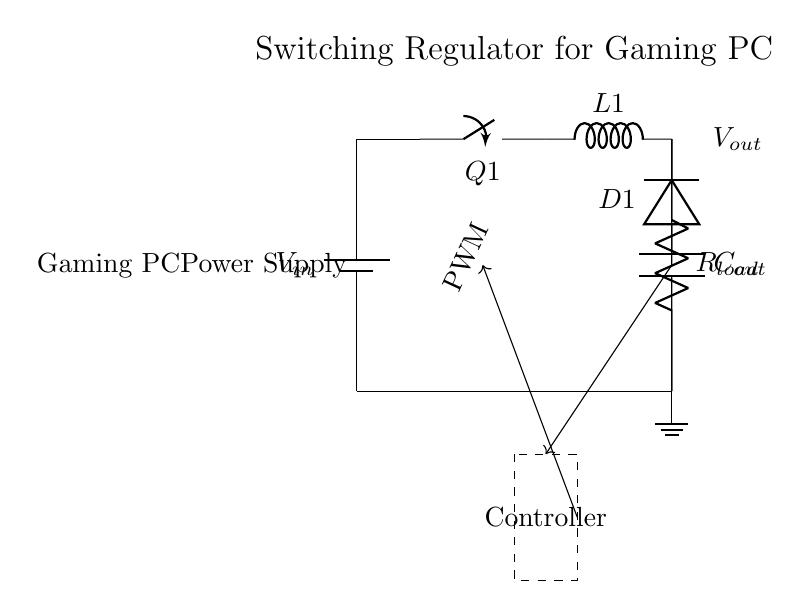What is the input voltage for this regulator circuit? The input voltage is denoted as V_{in} in the circuit diagram, indicating the supply voltage fed into the regulator.
Answer: V_{in} What component is represented by D1? D1 is labeled as a diode in the circuit diagram, which is responsible for allowing current to flow in one direction and blocking it in the reverse direction.
Answer: Diode What does the output capacitor C_{out} do in this circuit? The output capacitor C_{out} is used to smooth the output voltage by filtering out voltage ripples, ensuring that the load receives a steady DC voltage.
Answer: Smooths voltage What is the function of the switch Q1? The switch Q1 is key in controlling the flow of current through the inductor L1, allowing the circuit to switch on and off rapidly to manage the output voltage.
Answer: Controls current What type of switching regulator is depicted by this circuit? This circuit represents a buck converter, which steps down the voltage from the input to a lower output voltage while maintaining efficiency.
Answer: Buck converter How does the feedback mechanism work in this circuit? The feedback mechanism operates by comparing the output voltage with a reference voltage, adjusting the PWM signal to maintain the desired output voltage regardless of load changes.
Answer: Adjusts PWM What does the PWM signal control in this switching regulator? The PWM signal controls the timing of the switch Q1, regulating how long it stays on and off to manage the output voltage based on feedback.
Answer: Switch timing 